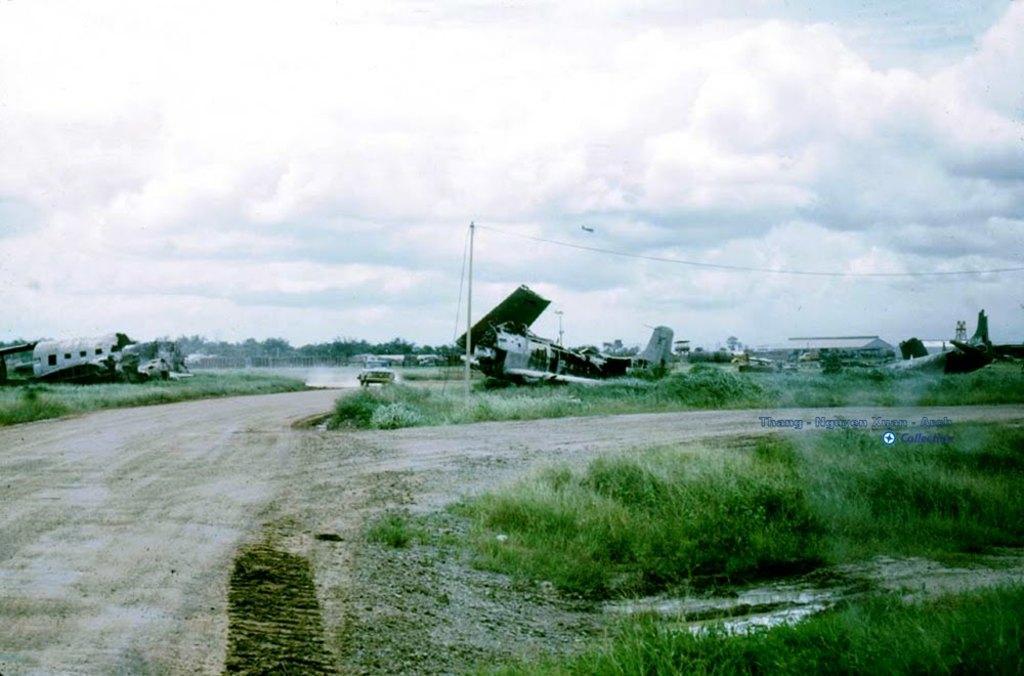Could you give a brief overview of what you see in this image? In this image I can see the road, some grass on the ground, few damaged aircrafts and few vehicles. In the background I can see few trees, a pole and the sky. 